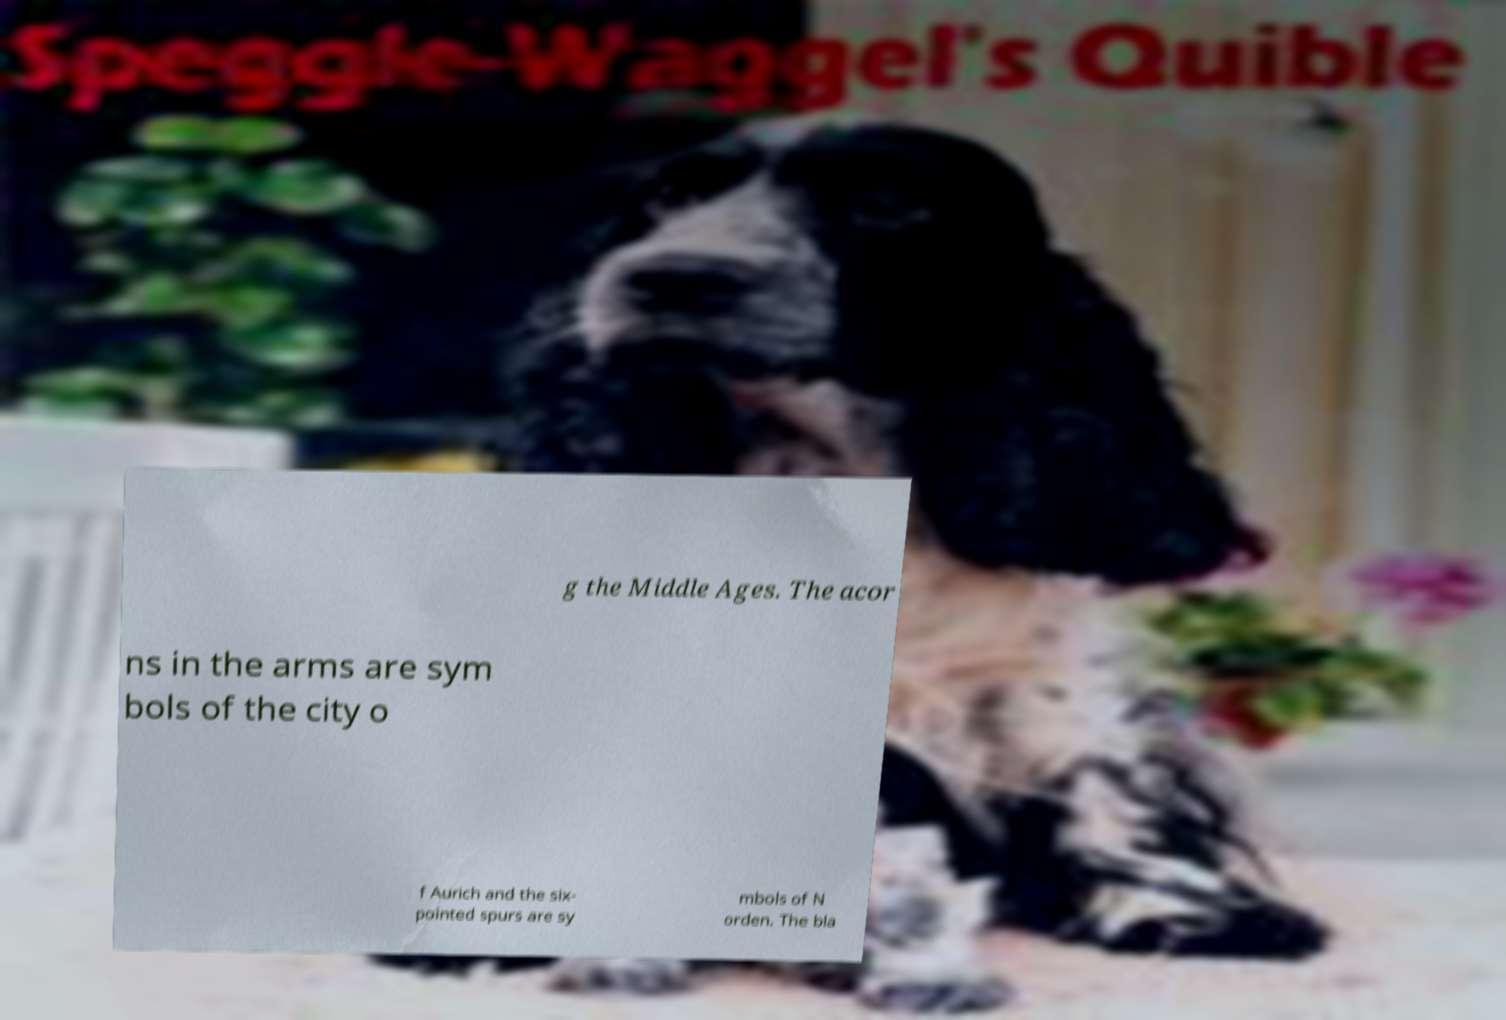Please identify and transcribe the text found in this image. g the Middle Ages. The acor ns in the arms are sym bols of the city o f Aurich and the six- pointed spurs are sy mbols of N orden. The bla 